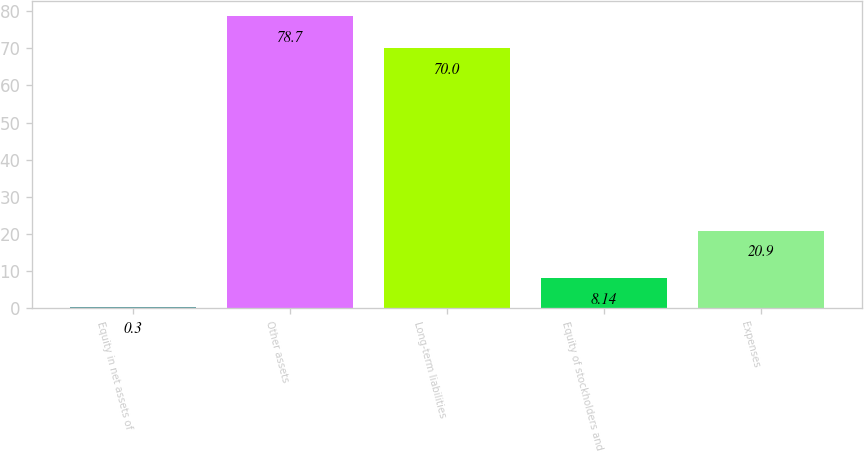Convert chart. <chart><loc_0><loc_0><loc_500><loc_500><bar_chart><fcel>Equity in net assets of<fcel>Other assets<fcel>Long-term liabilities<fcel>Equity of stockholders and<fcel>Expenses<nl><fcel>0.3<fcel>78.7<fcel>70<fcel>8.14<fcel>20.9<nl></chart> 